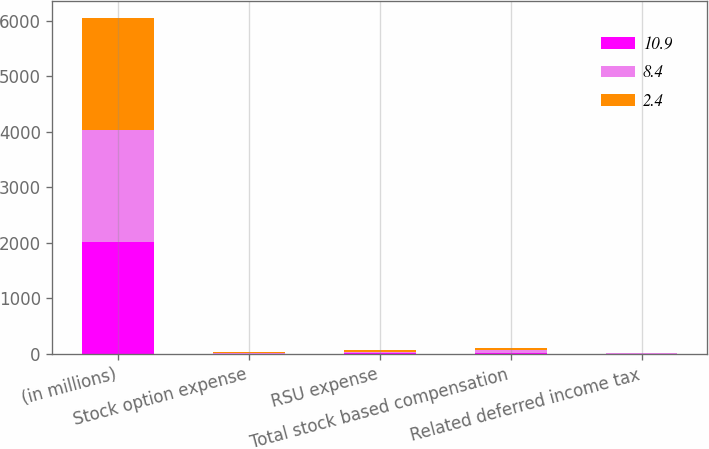Convert chart to OTSL. <chart><loc_0><loc_0><loc_500><loc_500><stacked_bar_chart><ecel><fcel>(in millions)<fcel>Stock option expense<fcel>RSU expense<fcel>Total stock based compensation<fcel>Related deferred income tax<nl><fcel>10.9<fcel>2018<fcel>6.6<fcel>13.2<fcel>19.8<fcel>2.4<nl><fcel>8.4<fcel>2017<fcel>15.4<fcel>31.2<fcel>46.6<fcel>8.4<nl><fcel>2.4<fcel>2016<fcel>10.6<fcel>29.1<fcel>39.7<fcel>10.9<nl></chart> 